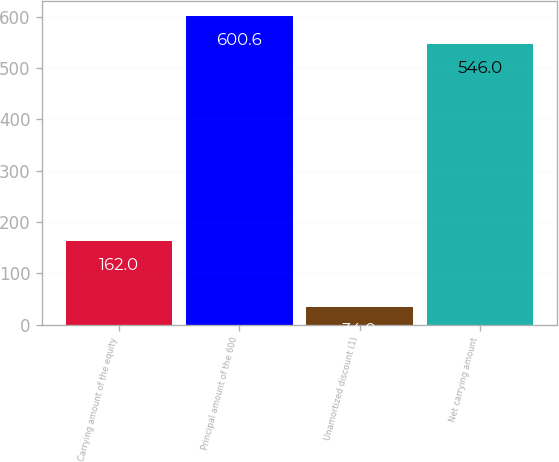<chart> <loc_0><loc_0><loc_500><loc_500><bar_chart><fcel>Carrying amount of the equity<fcel>Principal amount of the 600<fcel>Unamortized discount (1)<fcel>Net carrying amount<nl><fcel>162<fcel>600.6<fcel>34<fcel>546<nl></chart> 